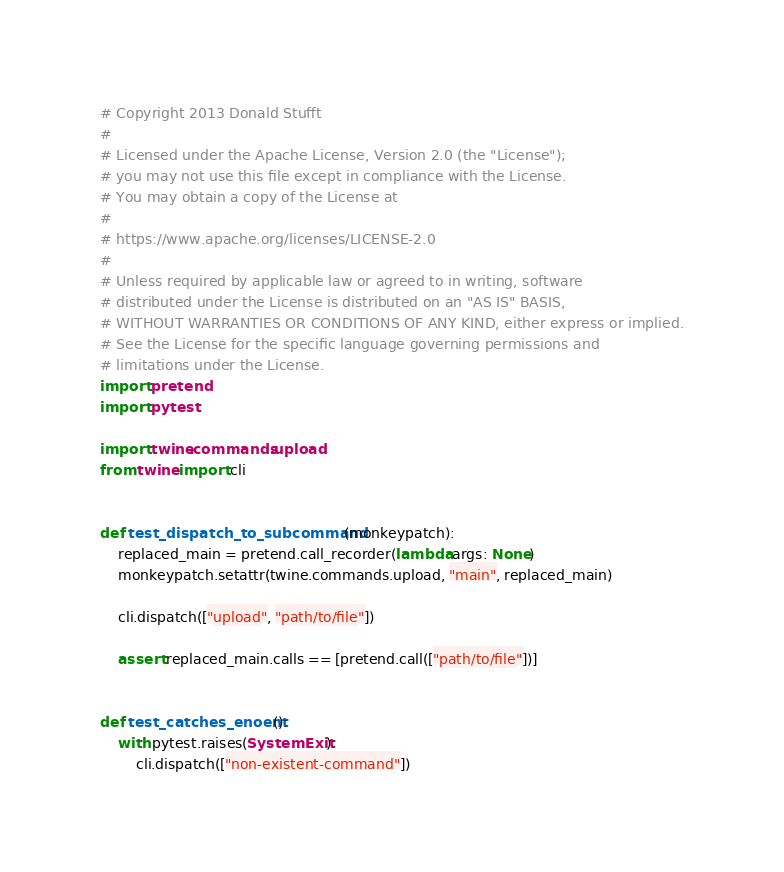Convert code to text. <code><loc_0><loc_0><loc_500><loc_500><_Python_># Copyright 2013 Donald Stufft
#
# Licensed under the Apache License, Version 2.0 (the "License");
# you may not use this file except in compliance with the License.
# You may obtain a copy of the License at
#
# https://www.apache.org/licenses/LICENSE-2.0
#
# Unless required by applicable law or agreed to in writing, software
# distributed under the License is distributed on an "AS IS" BASIS,
# WITHOUT WARRANTIES OR CONDITIONS OF ANY KIND, either express or implied.
# See the License for the specific language governing permissions and
# limitations under the License.
import pretend
import pytest

import twine.commands.upload
from twine import cli


def test_dispatch_to_subcommand(monkeypatch):
    replaced_main = pretend.call_recorder(lambda args: None)
    monkeypatch.setattr(twine.commands.upload, "main", replaced_main)

    cli.dispatch(["upload", "path/to/file"])

    assert replaced_main.calls == [pretend.call(["path/to/file"])]


def test_catches_enoent():
    with pytest.raises(SystemExit):
        cli.dispatch(["non-existent-command"])
</code> 